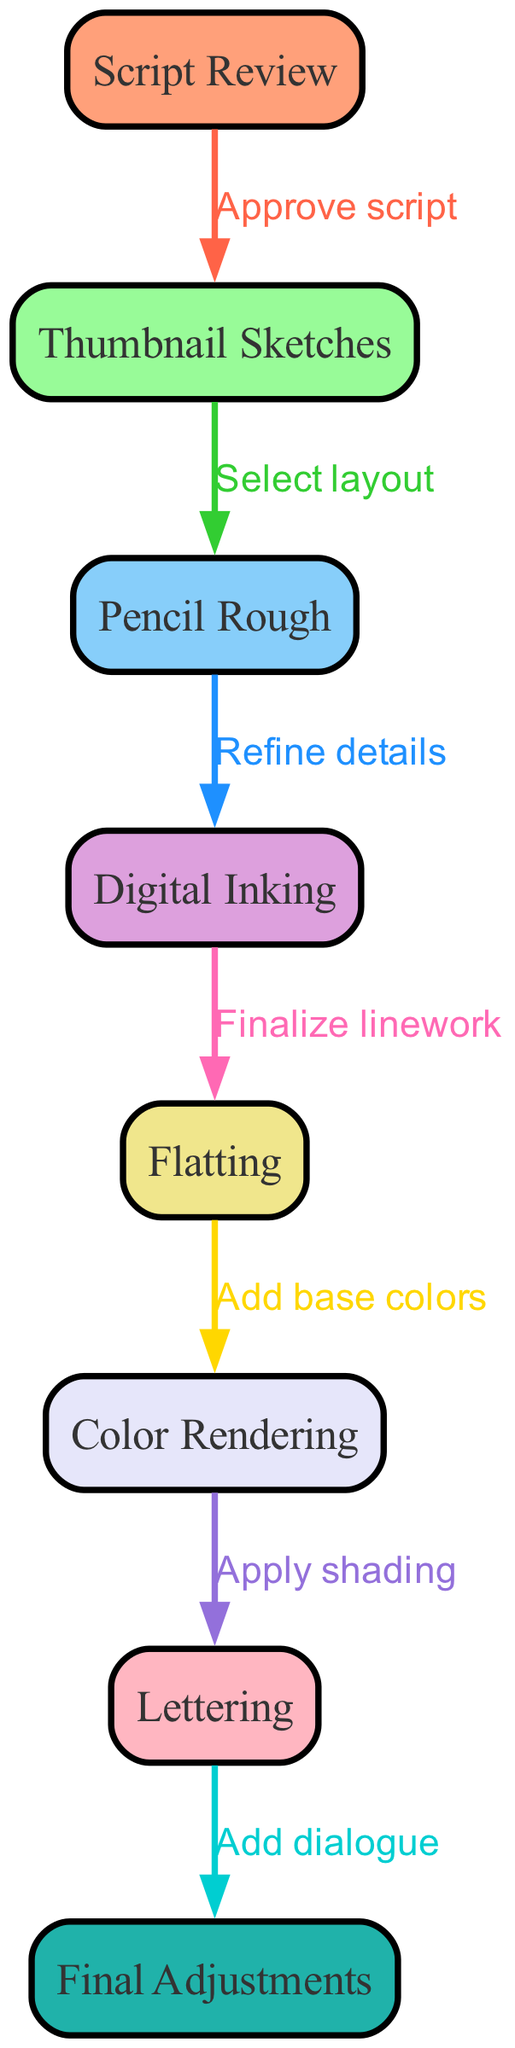What is the first step in the workflow? The first step in the workflow, represented by the first node, is "Script Review". This is where the script is evaluated before any graphical work begins.
Answer: Script Review How many nodes are in the diagram? To find the total number of nodes, we count each individual node depicted. There are eight distinct nodes listed in the provided data.
Answer: 8 What is the last step before final adjustments? The last step before "Final Adjustments" is "Lettering". This step involves adding dialogue to the artwork, which is crucial for the final presentation before adjustments.
Answer: Lettering Which node follows "Flatting"? "Color Rendering" follows "Flatting". This happens after the base colors have been applied to the artwork, indicating the transition to adding further color detail.
Answer: Color Rendering What is the relationship between "Pencil Rough" and "Digital Inking"? The relationship is described as "Refine details". This means that after creating the pencil roughs, the artist refines the details before moving on to digital inking.
Answer: Refine details How are the edges in the diagram color-coded? The edges in the diagram are color-coded using a custom palette where each edge corresponds to different colors representing various steps. Each transition from one node to another has a unique color.
Answer: Custom color palette What is the process that follows adding base colors? The process that follows adding base colors is "Color Rendering". This involves enhancing the artwork by applying additional colors and shading to create depth and vibrancy.
Answer: Color Rendering What is required before moving from "Thumbnail Sketches" to "Pencil Rough"? Before moving from "Thumbnail Sketches" to "Pencil Rough", the script must be approved, ensuring that the chosen layout is aligned with the overall story before detailing it.
Answer: Approve script 